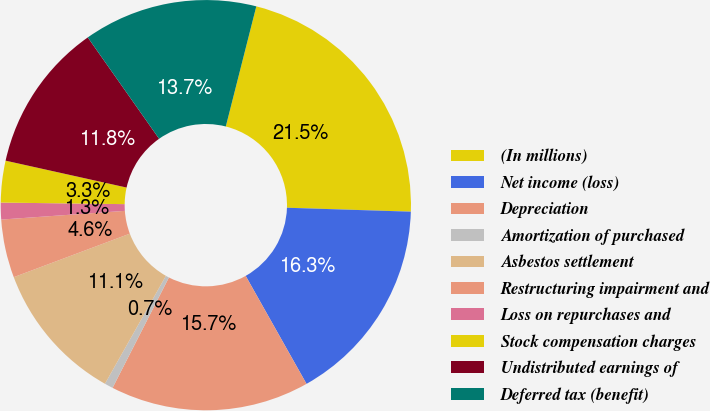Convert chart. <chart><loc_0><loc_0><loc_500><loc_500><pie_chart><fcel>(In millions)<fcel>Net income (loss)<fcel>Depreciation<fcel>Amortization of purchased<fcel>Asbestos settlement<fcel>Restructuring impairment and<fcel>Loss on repurchases and<fcel>Stock compensation charges<fcel>Undistributed earnings of<fcel>Deferred tax (benefit)<nl><fcel>21.55%<fcel>16.33%<fcel>15.68%<fcel>0.67%<fcel>11.11%<fcel>4.59%<fcel>1.32%<fcel>3.28%<fcel>11.76%<fcel>13.72%<nl></chart> 